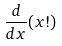<formula> <loc_0><loc_0><loc_500><loc_500>\frac { d } { d x } ( x ! )</formula> 